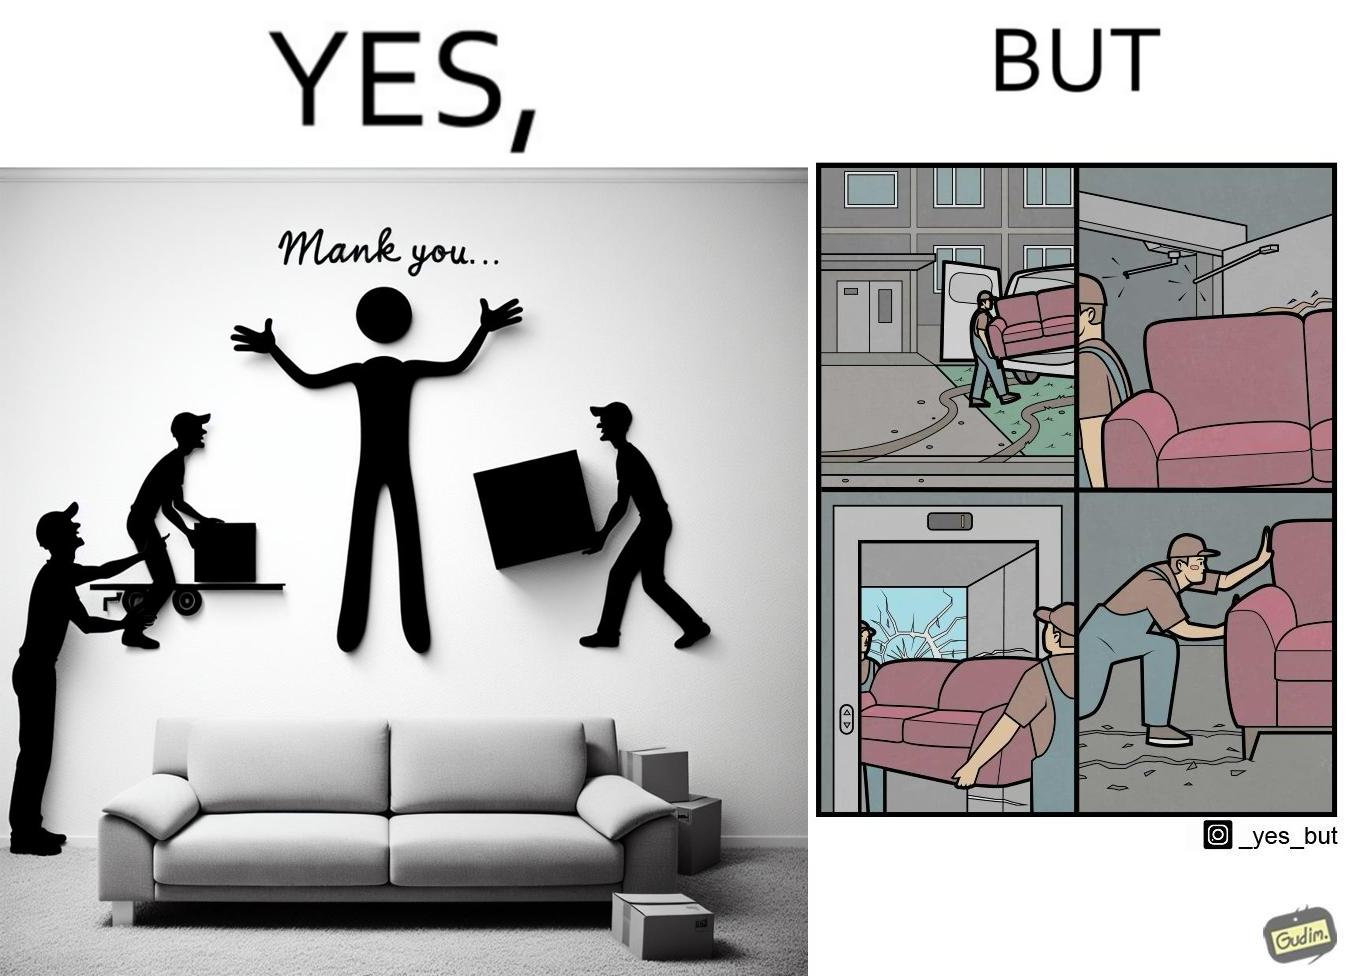Is this a satirical image? Yes, this image is satirical. 